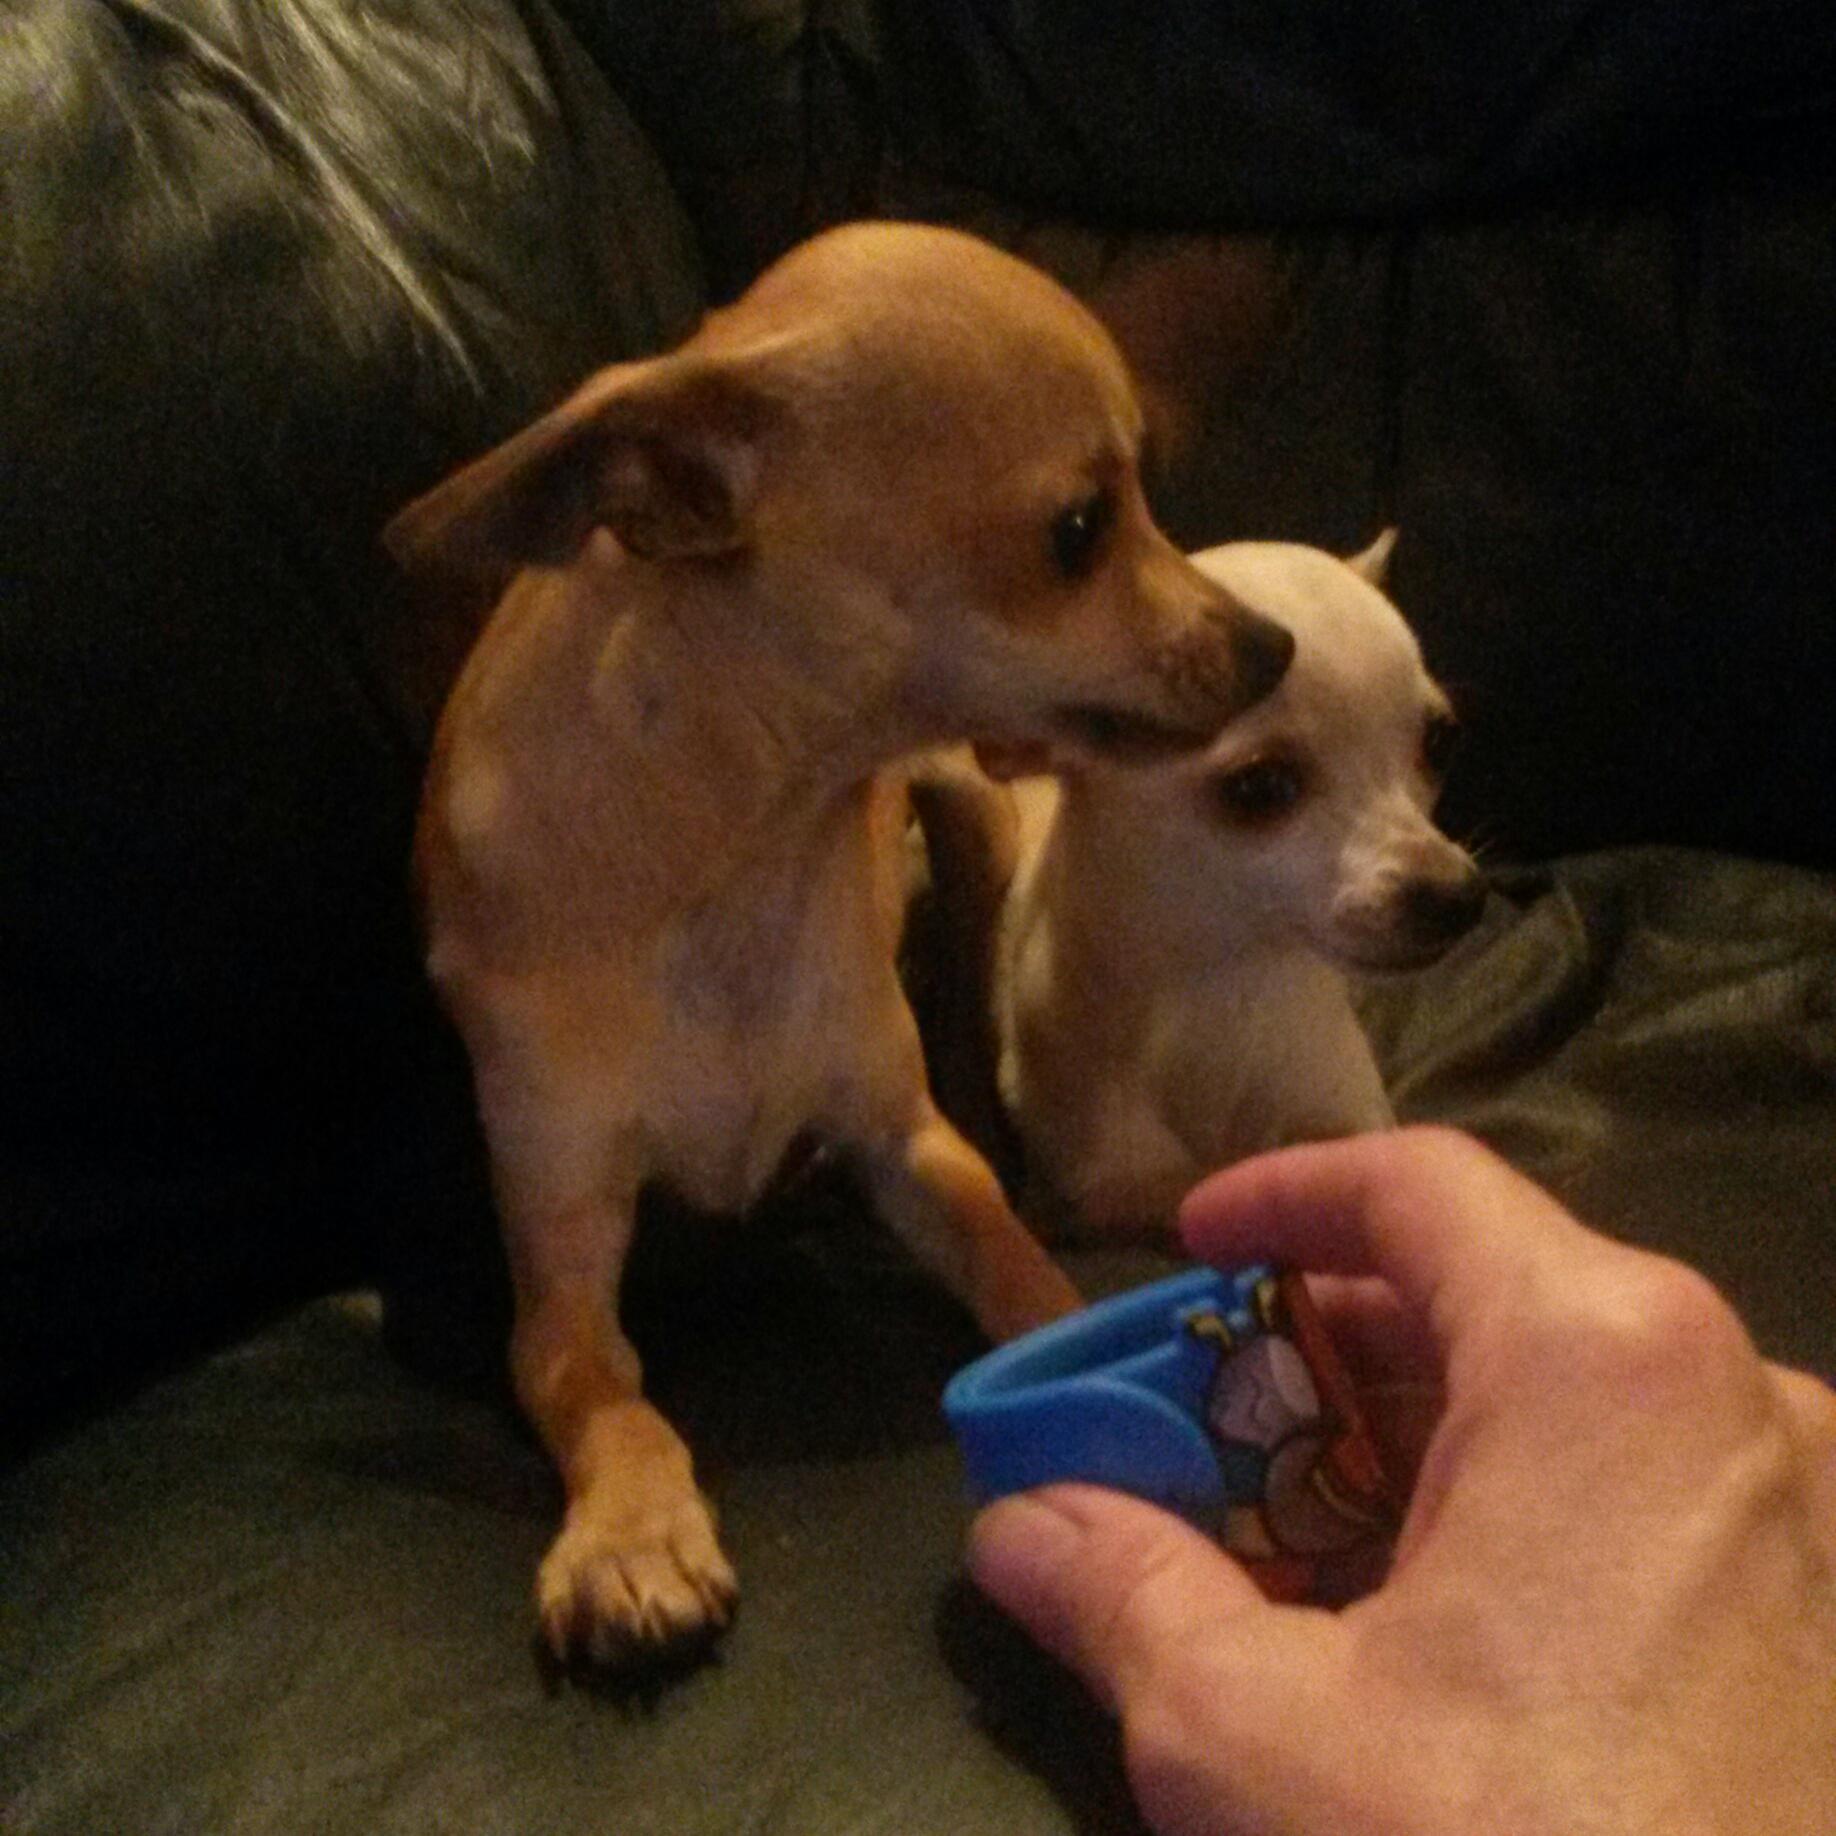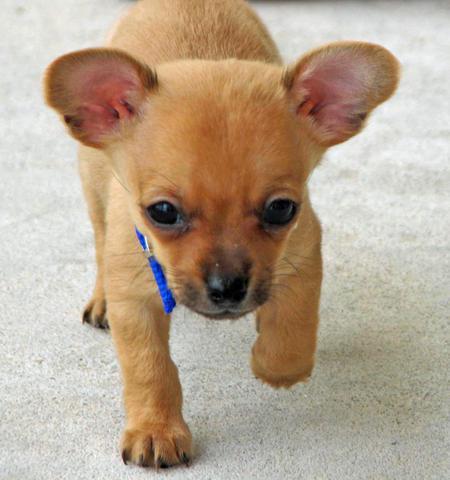The first image is the image on the left, the second image is the image on the right. For the images displayed, is the sentence "The right image contains a black and white chihuahua that is wearing a red collar." factually correct? Answer yes or no. No. The first image is the image on the left, the second image is the image on the right. Examine the images to the left and right. Is the description "Each image contains exactly one dog, and the right image features a black-and-white dog wearing a red collar." accurate? Answer yes or no. No. 